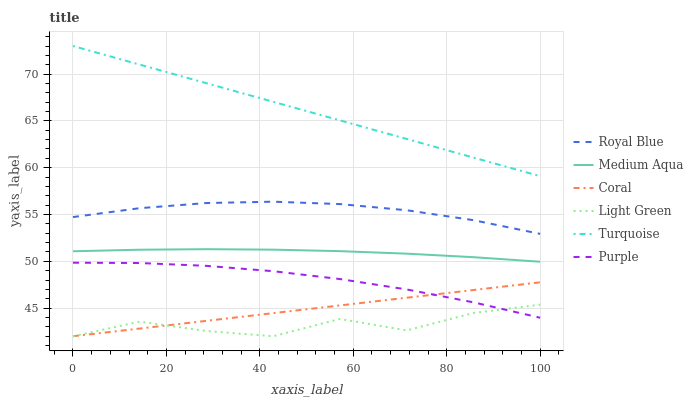Does Light Green have the minimum area under the curve?
Answer yes or no. Yes. Does Turquoise have the maximum area under the curve?
Answer yes or no. Yes. Does Purple have the minimum area under the curve?
Answer yes or no. No. Does Purple have the maximum area under the curve?
Answer yes or no. No. Is Turquoise the smoothest?
Answer yes or no. Yes. Is Light Green the roughest?
Answer yes or no. Yes. Is Purple the smoothest?
Answer yes or no. No. Is Purple the roughest?
Answer yes or no. No. Does Coral have the lowest value?
Answer yes or no. Yes. Does Purple have the lowest value?
Answer yes or no. No. Does Turquoise have the highest value?
Answer yes or no. Yes. Does Purple have the highest value?
Answer yes or no. No. Is Coral less than Turquoise?
Answer yes or no. Yes. Is Medium Aqua greater than Light Green?
Answer yes or no. Yes. Does Purple intersect Coral?
Answer yes or no. Yes. Is Purple less than Coral?
Answer yes or no. No. Is Purple greater than Coral?
Answer yes or no. No. Does Coral intersect Turquoise?
Answer yes or no. No. 